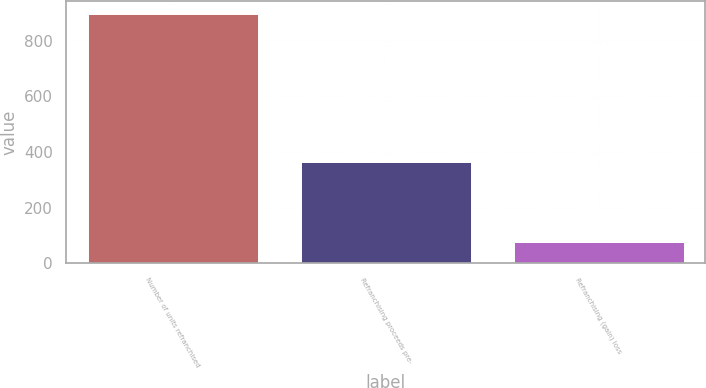Convert chart to OTSL. <chart><loc_0><loc_0><loc_500><loc_500><bar_chart><fcel>Number of units refranchised<fcel>Refranchising proceeds pre-<fcel>Refranchising (gain) loss<nl><fcel>897<fcel>364<fcel>78<nl></chart> 